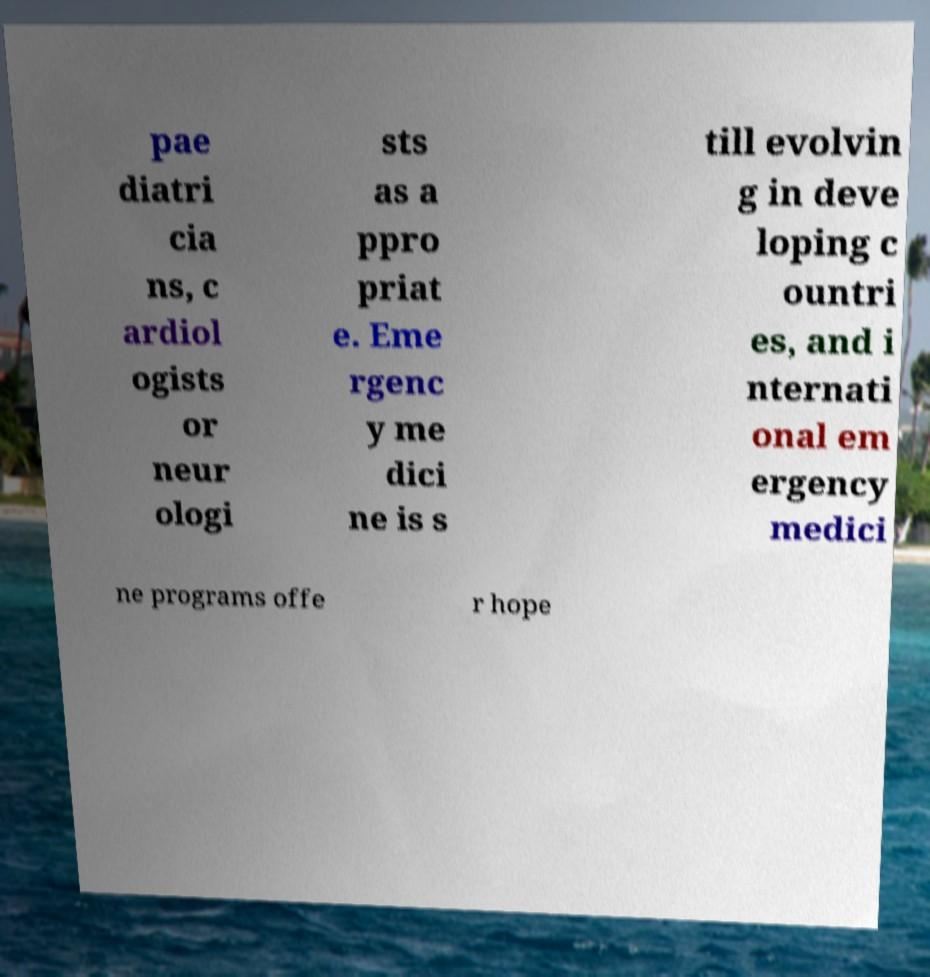What messages or text are displayed in this image? I need them in a readable, typed format. pae diatri cia ns, c ardiol ogists or neur ologi sts as a ppro priat e. Eme rgenc y me dici ne is s till evolvin g in deve loping c ountri es, and i nternati onal em ergency medici ne programs offe r hope 